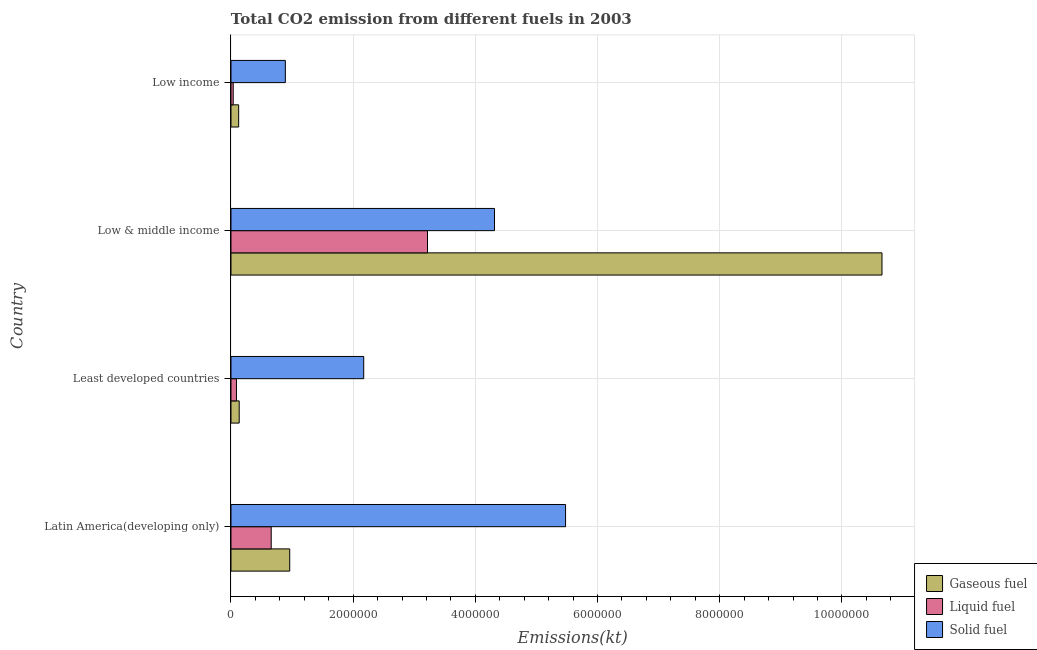How many different coloured bars are there?
Your response must be concise. 3. Are the number of bars per tick equal to the number of legend labels?
Your answer should be very brief. Yes. How many bars are there on the 3rd tick from the top?
Provide a short and direct response. 3. How many bars are there on the 3rd tick from the bottom?
Keep it short and to the point. 3. What is the label of the 2nd group of bars from the top?
Offer a terse response. Low & middle income. In how many cases, is the number of bars for a given country not equal to the number of legend labels?
Your answer should be compact. 0. What is the amount of co2 emissions from solid fuel in Least developed countries?
Your answer should be very brief. 2.17e+06. Across all countries, what is the maximum amount of co2 emissions from solid fuel?
Your answer should be compact. 5.48e+06. Across all countries, what is the minimum amount of co2 emissions from liquid fuel?
Make the answer very short. 3.68e+04. In which country was the amount of co2 emissions from gaseous fuel maximum?
Your response must be concise. Low & middle income. In which country was the amount of co2 emissions from gaseous fuel minimum?
Make the answer very short. Low income. What is the total amount of co2 emissions from liquid fuel in the graph?
Your response must be concise. 4.00e+06. What is the difference between the amount of co2 emissions from liquid fuel in Least developed countries and that in Low & middle income?
Your response must be concise. -3.13e+06. What is the difference between the amount of co2 emissions from gaseous fuel in Low & middle income and the amount of co2 emissions from liquid fuel in Low income?
Provide a short and direct response. 1.06e+07. What is the average amount of co2 emissions from gaseous fuel per country?
Provide a short and direct response. 2.97e+06. What is the difference between the amount of co2 emissions from solid fuel and amount of co2 emissions from liquid fuel in Latin America(developing only)?
Make the answer very short. 4.82e+06. What is the ratio of the amount of co2 emissions from gaseous fuel in Latin America(developing only) to that in Least developed countries?
Your answer should be compact. 7.14. Is the difference between the amount of co2 emissions from gaseous fuel in Latin America(developing only) and Low income greater than the difference between the amount of co2 emissions from solid fuel in Latin America(developing only) and Low income?
Ensure brevity in your answer.  No. What is the difference between the highest and the second highest amount of co2 emissions from gaseous fuel?
Provide a succinct answer. 9.69e+06. What is the difference between the highest and the lowest amount of co2 emissions from liquid fuel?
Make the answer very short. 3.18e+06. In how many countries, is the amount of co2 emissions from solid fuel greater than the average amount of co2 emissions from solid fuel taken over all countries?
Keep it short and to the point. 2. Is the sum of the amount of co2 emissions from solid fuel in Least developed countries and Low & middle income greater than the maximum amount of co2 emissions from liquid fuel across all countries?
Make the answer very short. Yes. What does the 2nd bar from the top in Low income represents?
Offer a very short reply. Liquid fuel. What does the 3rd bar from the bottom in Least developed countries represents?
Provide a short and direct response. Solid fuel. Is it the case that in every country, the sum of the amount of co2 emissions from gaseous fuel and amount of co2 emissions from liquid fuel is greater than the amount of co2 emissions from solid fuel?
Offer a very short reply. No. Are all the bars in the graph horizontal?
Make the answer very short. Yes. How many countries are there in the graph?
Your answer should be very brief. 4. What is the difference between two consecutive major ticks on the X-axis?
Give a very brief answer. 2.00e+06. Does the graph contain any zero values?
Your answer should be very brief. No. Where does the legend appear in the graph?
Offer a very short reply. Bottom right. How many legend labels are there?
Make the answer very short. 3. What is the title of the graph?
Offer a very short reply. Total CO2 emission from different fuels in 2003. What is the label or title of the X-axis?
Make the answer very short. Emissions(kt). What is the Emissions(kt) of Gaseous fuel in Latin America(developing only)?
Ensure brevity in your answer.  9.62e+05. What is the Emissions(kt) of Liquid fuel in Latin America(developing only)?
Give a very brief answer. 6.58e+05. What is the Emissions(kt) in Solid fuel in Latin America(developing only)?
Ensure brevity in your answer.  5.48e+06. What is the Emissions(kt) in Gaseous fuel in Least developed countries?
Your answer should be very brief. 1.35e+05. What is the Emissions(kt) of Liquid fuel in Least developed countries?
Offer a very short reply. 8.99e+04. What is the Emissions(kt) of Solid fuel in Least developed countries?
Your answer should be compact. 2.17e+06. What is the Emissions(kt) in Gaseous fuel in Low & middle income?
Your answer should be compact. 1.07e+07. What is the Emissions(kt) of Liquid fuel in Low & middle income?
Ensure brevity in your answer.  3.22e+06. What is the Emissions(kt) in Solid fuel in Low & middle income?
Keep it short and to the point. 4.31e+06. What is the Emissions(kt) in Gaseous fuel in Low income?
Your answer should be very brief. 1.26e+05. What is the Emissions(kt) in Liquid fuel in Low income?
Give a very brief answer. 3.68e+04. What is the Emissions(kt) in Solid fuel in Low income?
Give a very brief answer. 8.90e+05. Across all countries, what is the maximum Emissions(kt) in Gaseous fuel?
Your answer should be very brief. 1.07e+07. Across all countries, what is the maximum Emissions(kt) in Liquid fuel?
Keep it short and to the point. 3.22e+06. Across all countries, what is the maximum Emissions(kt) in Solid fuel?
Provide a succinct answer. 5.48e+06. Across all countries, what is the minimum Emissions(kt) in Gaseous fuel?
Ensure brevity in your answer.  1.26e+05. Across all countries, what is the minimum Emissions(kt) in Liquid fuel?
Keep it short and to the point. 3.68e+04. Across all countries, what is the minimum Emissions(kt) in Solid fuel?
Provide a succinct answer. 8.90e+05. What is the total Emissions(kt) of Gaseous fuel in the graph?
Your answer should be very brief. 1.19e+07. What is the total Emissions(kt) in Liquid fuel in the graph?
Provide a short and direct response. 4.00e+06. What is the total Emissions(kt) of Solid fuel in the graph?
Give a very brief answer. 1.29e+07. What is the difference between the Emissions(kt) of Gaseous fuel in Latin America(developing only) and that in Least developed countries?
Your answer should be very brief. 8.27e+05. What is the difference between the Emissions(kt) of Liquid fuel in Latin America(developing only) and that in Least developed countries?
Give a very brief answer. 5.69e+05. What is the difference between the Emissions(kt) in Solid fuel in Latin America(developing only) and that in Least developed countries?
Make the answer very short. 3.30e+06. What is the difference between the Emissions(kt) of Gaseous fuel in Latin America(developing only) and that in Low & middle income?
Ensure brevity in your answer.  -9.69e+06. What is the difference between the Emissions(kt) of Liquid fuel in Latin America(developing only) and that in Low & middle income?
Ensure brevity in your answer.  -2.56e+06. What is the difference between the Emissions(kt) in Solid fuel in Latin America(developing only) and that in Low & middle income?
Keep it short and to the point. 1.16e+06. What is the difference between the Emissions(kt) in Gaseous fuel in Latin America(developing only) and that in Low income?
Provide a short and direct response. 8.36e+05. What is the difference between the Emissions(kt) of Liquid fuel in Latin America(developing only) and that in Low income?
Your answer should be compact. 6.22e+05. What is the difference between the Emissions(kt) of Solid fuel in Latin America(developing only) and that in Low income?
Your answer should be very brief. 4.59e+06. What is the difference between the Emissions(kt) of Gaseous fuel in Least developed countries and that in Low & middle income?
Keep it short and to the point. -1.05e+07. What is the difference between the Emissions(kt) in Liquid fuel in Least developed countries and that in Low & middle income?
Offer a terse response. -3.13e+06. What is the difference between the Emissions(kt) of Solid fuel in Least developed countries and that in Low & middle income?
Provide a succinct answer. -2.14e+06. What is the difference between the Emissions(kt) of Gaseous fuel in Least developed countries and that in Low income?
Provide a short and direct response. 8969.29. What is the difference between the Emissions(kt) in Liquid fuel in Least developed countries and that in Low income?
Offer a terse response. 5.31e+04. What is the difference between the Emissions(kt) in Solid fuel in Least developed countries and that in Low income?
Provide a short and direct response. 1.28e+06. What is the difference between the Emissions(kt) of Gaseous fuel in Low & middle income and that in Low income?
Your response must be concise. 1.05e+07. What is the difference between the Emissions(kt) in Liquid fuel in Low & middle income and that in Low income?
Provide a succinct answer. 3.18e+06. What is the difference between the Emissions(kt) of Solid fuel in Low & middle income and that in Low income?
Provide a succinct answer. 3.42e+06. What is the difference between the Emissions(kt) in Gaseous fuel in Latin America(developing only) and the Emissions(kt) in Liquid fuel in Least developed countries?
Your response must be concise. 8.72e+05. What is the difference between the Emissions(kt) in Gaseous fuel in Latin America(developing only) and the Emissions(kt) in Solid fuel in Least developed countries?
Your answer should be compact. -1.21e+06. What is the difference between the Emissions(kt) in Liquid fuel in Latin America(developing only) and the Emissions(kt) in Solid fuel in Least developed countries?
Your answer should be compact. -1.51e+06. What is the difference between the Emissions(kt) in Gaseous fuel in Latin America(developing only) and the Emissions(kt) in Liquid fuel in Low & middle income?
Your answer should be very brief. -2.26e+06. What is the difference between the Emissions(kt) of Gaseous fuel in Latin America(developing only) and the Emissions(kt) of Solid fuel in Low & middle income?
Ensure brevity in your answer.  -3.35e+06. What is the difference between the Emissions(kt) of Liquid fuel in Latin America(developing only) and the Emissions(kt) of Solid fuel in Low & middle income?
Make the answer very short. -3.66e+06. What is the difference between the Emissions(kt) in Gaseous fuel in Latin America(developing only) and the Emissions(kt) in Liquid fuel in Low income?
Your answer should be very brief. 9.25e+05. What is the difference between the Emissions(kt) in Gaseous fuel in Latin America(developing only) and the Emissions(kt) in Solid fuel in Low income?
Ensure brevity in your answer.  7.17e+04. What is the difference between the Emissions(kt) of Liquid fuel in Latin America(developing only) and the Emissions(kt) of Solid fuel in Low income?
Provide a short and direct response. -2.32e+05. What is the difference between the Emissions(kt) of Gaseous fuel in Least developed countries and the Emissions(kt) of Liquid fuel in Low & middle income?
Offer a terse response. -3.08e+06. What is the difference between the Emissions(kt) in Gaseous fuel in Least developed countries and the Emissions(kt) in Solid fuel in Low & middle income?
Provide a succinct answer. -4.18e+06. What is the difference between the Emissions(kt) of Liquid fuel in Least developed countries and the Emissions(kt) of Solid fuel in Low & middle income?
Your answer should be very brief. -4.22e+06. What is the difference between the Emissions(kt) in Gaseous fuel in Least developed countries and the Emissions(kt) in Liquid fuel in Low income?
Make the answer very short. 9.79e+04. What is the difference between the Emissions(kt) of Gaseous fuel in Least developed countries and the Emissions(kt) of Solid fuel in Low income?
Ensure brevity in your answer.  -7.55e+05. What is the difference between the Emissions(kt) in Liquid fuel in Least developed countries and the Emissions(kt) in Solid fuel in Low income?
Provide a short and direct response. -8.00e+05. What is the difference between the Emissions(kt) of Gaseous fuel in Low & middle income and the Emissions(kt) of Liquid fuel in Low income?
Provide a succinct answer. 1.06e+07. What is the difference between the Emissions(kt) of Gaseous fuel in Low & middle income and the Emissions(kt) of Solid fuel in Low income?
Your answer should be very brief. 9.77e+06. What is the difference between the Emissions(kt) in Liquid fuel in Low & middle income and the Emissions(kt) in Solid fuel in Low income?
Provide a short and direct response. 2.33e+06. What is the average Emissions(kt) of Gaseous fuel per country?
Your response must be concise. 2.97e+06. What is the average Emissions(kt) of Liquid fuel per country?
Provide a short and direct response. 1.00e+06. What is the average Emissions(kt) in Solid fuel per country?
Ensure brevity in your answer.  3.21e+06. What is the difference between the Emissions(kt) of Gaseous fuel and Emissions(kt) of Liquid fuel in Latin America(developing only)?
Offer a terse response. 3.03e+05. What is the difference between the Emissions(kt) of Gaseous fuel and Emissions(kt) of Solid fuel in Latin America(developing only)?
Your answer should be compact. -4.52e+06. What is the difference between the Emissions(kt) in Liquid fuel and Emissions(kt) in Solid fuel in Latin America(developing only)?
Give a very brief answer. -4.82e+06. What is the difference between the Emissions(kt) of Gaseous fuel and Emissions(kt) of Liquid fuel in Least developed countries?
Give a very brief answer. 4.48e+04. What is the difference between the Emissions(kt) of Gaseous fuel and Emissions(kt) of Solid fuel in Least developed countries?
Make the answer very short. -2.04e+06. What is the difference between the Emissions(kt) of Liquid fuel and Emissions(kt) of Solid fuel in Least developed countries?
Make the answer very short. -2.08e+06. What is the difference between the Emissions(kt) of Gaseous fuel and Emissions(kt) of Liquid fuel in Low & middle income?
Make the answer very short. 7.44e+06. What is the difference between the Emissions(kt) of Gaseous fuel and Emissions(kt) of Solid fuel in Low & middle income?
Provide a short and direct response. 6.34e+06. What is the difference between the Emissions(kt) of Liquid fuel and Emissions(kt) of Solid fuel in Low & middle income?
Make the answer very short. -1.10e+06. What is the difference between the Emissions(kt) in Gaseous fuel and Emissions(kt) in Liquid fuel in Low income?
Provide a succinct answer. 8.90e+04. What is the difference between the Emissions(kt) in Gaseous fuel and Emissions(kt) in Solid fuel in Low income?
Make the answer very short. -7.64e+05. What is the difference between the Emissions(kt) in Liquid fuel and Emissions(kt) in Solid fuel in Low income?
Give a very brief answer. -8.53e+05. What is the ratio of the Emissions(kt) of Gaseous fuel in Latin America(developing only) to that in Least developed countries?
Give a very brief answer. 7.14. What is the ratio of the Emissions(kt) in Liquid fuel in Latin America(developing only) to that in Least developed countries?
Your response must be concise. 7.32. What is the ratio of the Emissions(kt) of Solid fuel in Latin America(developing only) to that in Least developed countries?
Keep it short and to the point. 2.52. What is the ratio of the Emissions(kt) of Gaseous fuel in Latin America(developing only) to that in Low & middle income?
Offer a terse response. 0.09. What is the ratio of the Emissions(kt) of Liquid fuel in Latin America(developing only) to that in Low & middle income?
Make the answer very short. 0.2. What is the ratio of the Emissions(kt) of Solid fuel in Latin America(developing only) to that in Low & middle income?
Provide a succinct answer. 1.27. What is the ratio of the Emissions(kt) of Gaseous fuel in Latin America(developing only) to that in Low income?
Provide a short and direct response. 7.65. What is the ratio of the Emissions(kt) in Liquid fuel in Latin America(developing only) to that in Low income?
Your answer should be compact. 17.89. What is the ratio of the Emissions(kt) in Solid fuel in Latin America(developing only) to that in Low income?
Offer a very short reply. 6.15. What is the ratio of the Emissions(kt) of Gaseous fuel in Least developed countries to that in Low & middle income?
Your answer should be very brief. 0.01. What is the ratio of the Emissions(kt) of Liquid fuel in Least developed countries to that in Low & middle income?
Provide a succinct answer. 0.03. What is the ratio of the Emissions(kt) of Solid fuel in Least developed countries to that in Low & middle income?
Offer a very short reply. 0.5. What is the ratio of the Emissions(kt) in Gaseous fuel in Least developed countries to that in Low income?
Ensure brevity in your answer.  1.07. What is the ratio of the Emissions(kt) of Liquid fuel in Least developed countries to that in Low income?
Provide a short and direct response. 2.44. What is the ratio of the Emissions(kt) in Solid fuel in Least developed countries to that in Low income?
Keep it short and to the point. 2.44. What is the ratio of the Emissions(kt) in Gaseous fuel in Low & middle income to that in Low income?
Offer a terse response. 84.72. What is the ratio of the Emissions(kt) of Liquid fuel in Low & middle income to that in Low income?
Your answer should be very brief. 87.41. What is the ratio of the Emissions(kt) in Solid fuel in Low & middle income to that in Low income?
Ensure brevity in your answer.  4.85. What is the difference between the highest and the second highest Emissions(kt) of Gaseous fuel?
Your response must be concise. 9.69e+06. What is the difference between the highest and the second highest Emissions(kt) of Liquid fuel?
Provide a succinct answer. 2.56e+06. What is the difference between the highest and the second highest Emissions(kt) in Solid fuel?
Your answer should be compact. 1.16e+06. What is the difference between the highest and the lowest Emissions(kt) in Gaseous fuel?
Give a very brief answer. 1.05e+07. What is the difference between the highest and the lowest Emissions(kt) of Liquid fuel?
Your response must be concise. 3.18e+06. What is the difference between the highest and the lowest Emissions(kt) of Solid fuel?
Your answer should be compact. 4.59e+06. 